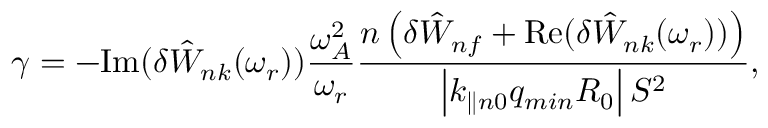Convert formula to latex. <formula><loc_0><loc_0><loc_500><loc_500>\gamma = - I m ( \delta { \hat { W } } _ { n k } ( \omega _ { r } ) ) \frac { \omega _ { A } ^ { 2 } } { \omega _ { r } } \frac { n \left ( \delta { \hat { W } } _ { n f } + R e ( { \delta { \hat { W } } _ { n k } ( \omega _ { r } ) ) } \right ) } { \left | k _ { \| n 0 } q _ { \min } R _ { 0 } \right | S ^ { 2 } } ,</formula> 